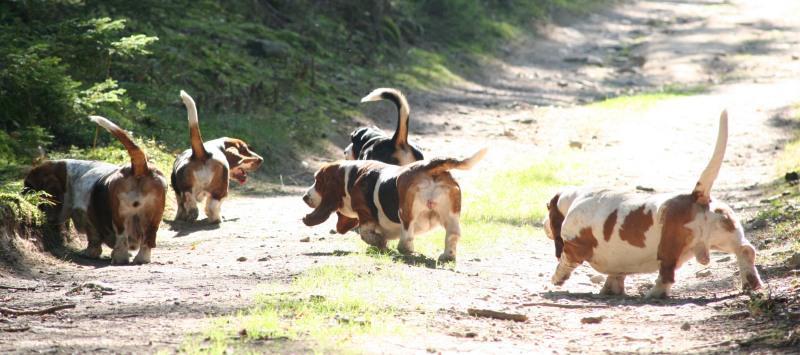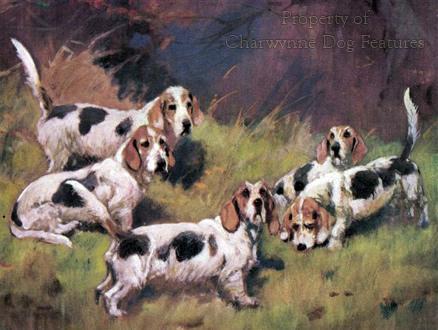The first image is the image on the left, the second image is the image on the right. Given the left and right images, does the statement "An image shows a person in a green jacket holding a whip and walking leftward with a pack of dogs." hold true? Answer yes or no. No. The first image is the image on the left, the second image is the image on the right. Assess this claim about the two images: "In one of the images there are at least two people surrounded by a group of hunting dogs.". Correct or not? Answer yes or no. No. 